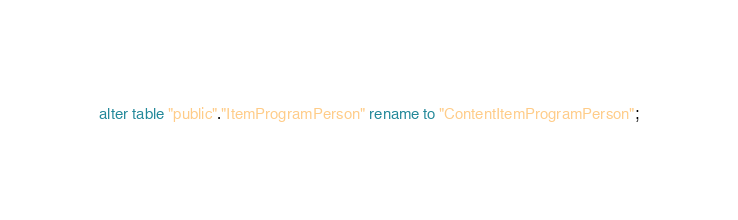<code> <loc_0><loc_0><loc_500><loc_500><_SQL_>alter table "public"."ItemProgramPerson" rename to "ContentItemProgramPerson";
</code> 